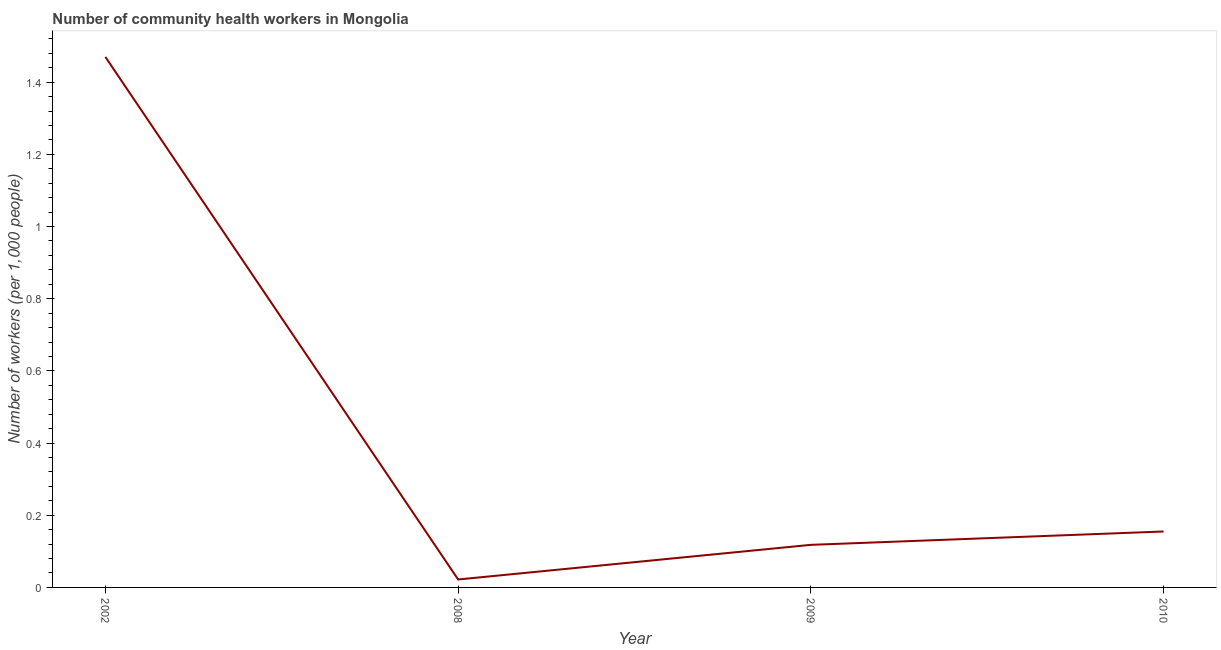What is the number of community health workers in 2002?
Make the answer very short. 1.47. Across all years, what is the maximum number of community health workers?
Your answer should be compact. 1.47. Across all years, what is the minimum number of community health workers?
Provide a short and direct response. 0.02. In which year was the number of community health workers maximum?
Keep it short and to the point. 2002. What is the sum of the number of community health workers?
Your answer should be compact. 1.76. What is the difference between the number of community health workers in 2002 and 2009?
Provide a short and direct response. 1.35. What is the average number of community health workers per year?
Your response must be concise. 0.44. What is the median number of community health workers?
Provide a succinct answer. 0.14. In how many years, is the number of community health workers greater than 0.92 ?
Offer a terse response. 1. Do a majority of the years between 2009 and 2008 (inclusive) have number of community health workers greater than 0.44 ?
Provide a short and direct response. No. What is the ratio of the number of community health workers in 2002 to that in 2008?
Your answer should be compact. 66.82. What is the difference between the highest and the second highest number of community health workers?
Offer a very short reply. 1.31. What is the difference between the highest and the lowest number of community health workers?
Provide a succinct answer. 1.45. In how many years, is the number of community health workers greater than the average number of community health workers taken over all years?
Offer a very short reply. 1. How many years are there in the graph?
Offer a terse response. 4. Are the values on the major ticks of Y-axis written in scientific E-notation?
Make the answer very short. No. Does the graph contain grids?
Ensure brevity in your answer.  No. What is the title of the graph?
Make the answer very short. Number of community health workers in Mongolia. What is the label or title of the X-axis?
Provide a succinct answer. Year. What is the label or title of the Y-axis?
Make the answer very short. Number of workers (per 1,0 people). What is the Number of workers (per 1,000 people) of 2002?
Ensure brevity in your answer.  1.47. What is the Number of workers (per 1,000 people) of 2008?
Make the answer very short. 0.02. What is the Number of workers (per 1,000 people) of 2009?
Offer a very short reply. 0.12. What is the Number of workers (per 1,000 people) of 2010?
Make the answer very short. 0.15. What is the difference between the Number of workers (per 1,000 people) in 2002 and 2008?
Ensure brevity in your answer.  1.45. What is the difference between the Number of workers (per 1,000 people) in 2002 and 2009?
Provide a short and direct response. 1.35. What is the difference between the Number of workers (per 1,000 people) in 2002 and 2010?
Your answer should be compact. 1.31. What is the difference between the Number of workers (per 1,000 people) in 2008 and 2009?
Your response must be concise. -0.1. What is the difference between the Number of workers (per 1,000 people) in 2008 and 2010?
Provide a succinct answer. -0.13. What is the difference between the Number of workers (per 1,000 people) in 2009 and 2010?
Your response must be concise. -0.04. What is the ratio of the Number of workers (per 1,000 people) in 2002 to that in 2008?
Your response must be concise. 66.82. What is the ratio of the Number of workers (per 1,000 people) in 2002 to that in 2009?
Provide a succinct answer. 12.46. What is the ratio of the Number of workers (per 1,000 people) in 2002 to that in 2010?
Give a very brief answer. 9.48. What is the ratio of the Number of workers (per 1,000 people) in 2008 to that in 2009?
Your answer should be compact. 0.19. What is the ratio of the Number of workers (per 1,000 people) in 2008 to that in 2010?
Your response must be concise. 0.14. What is the ratio of the Number of workers (per 1,000 people) in 2009 to that in 2010?
Give a very brief answer. 0.76. 